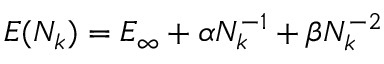Convert formula to latex. <formula><loc_0><loc_0><loc_500><loc_500>\begin{array} { r } { E ( N _ { k } ) = E _ { \infty } + \alpha N _ { k } ^ { - 1 } + \beta N _ { k } ^ { - 2 } } \end{array}</formula> 